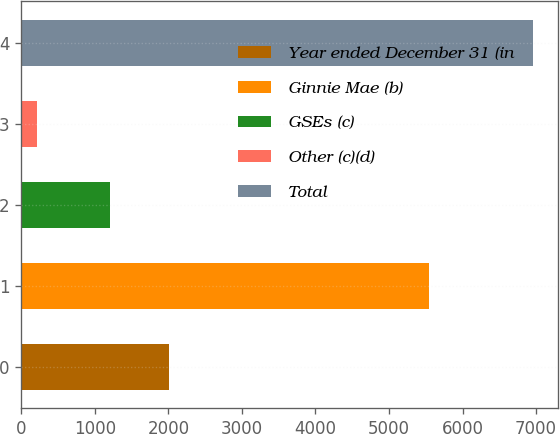<chart> <loc_0><loc_0><loc_500><loc_500><bar_chart><fcel>Year ended December 31 (in<fcel>Ginnie Mae (b)<fcel>GSEs (c)<fcel>Other (c)(d)<fcel>Total<nl><fcel>2012<fcel>5539<fcel>1204<fcel>209<fcel>6952<nl></chart> 